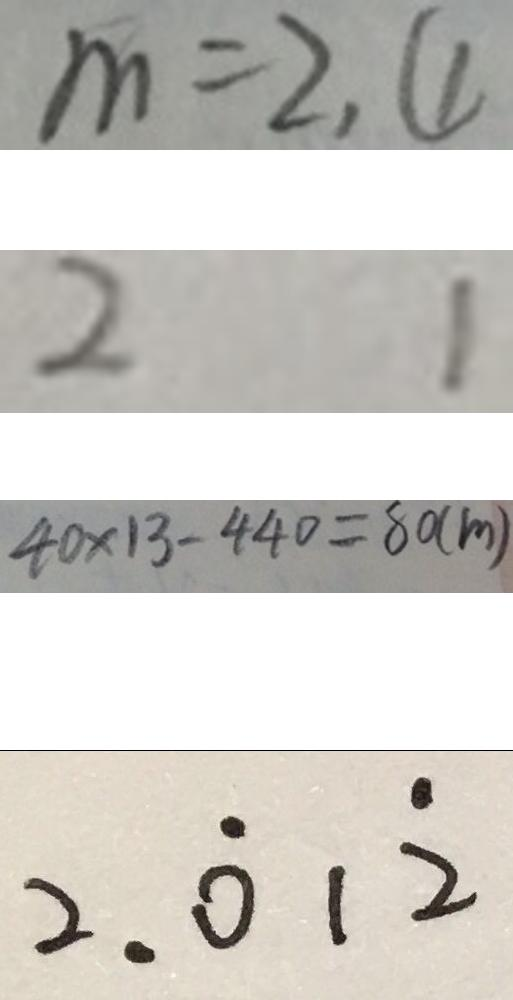Convert formula to latex. <formula><loc_0><loc_0><loc_500><loc_500>m = 2 , \textcircled { 1 } 
 2 1 
 4 0 \times 1 3 - 4 4 0 = 8 0 ( m ) 
 2 . \dot { 0 } 1 \dot { 2 }</formula> 